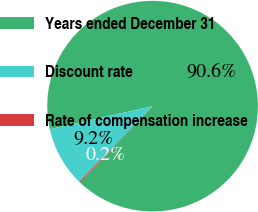Convert chart. <chart><loc_0><loc_0><loc_500><loc_500><pie_chart><fcel>Years ended December 31<fcel>Discount rate<fcel>Rate of compensation increase<nl><fcel>90.6%<fcel>9.22%<fcel>0.18%<nl></chart> 